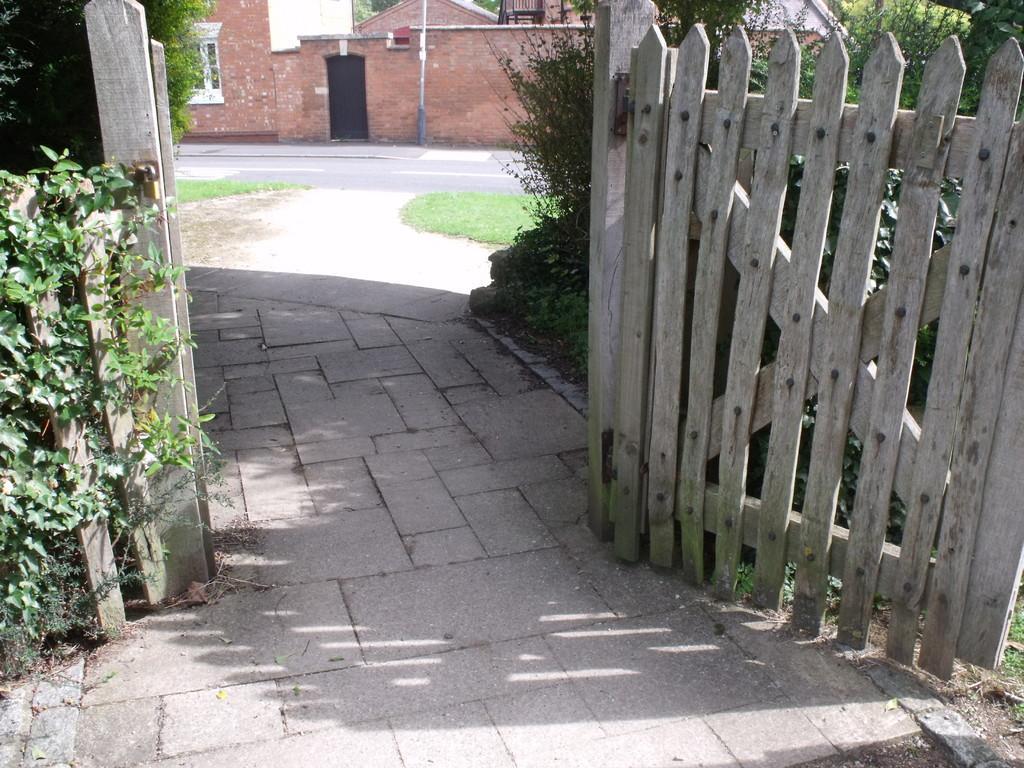Could you give a brief overview of what you see in this image? In this image I can see a wooden gate on the right side and on the left side of this image I can see number of green colour leaves. In the background I can see a road, grass, few trees and few buildings. 